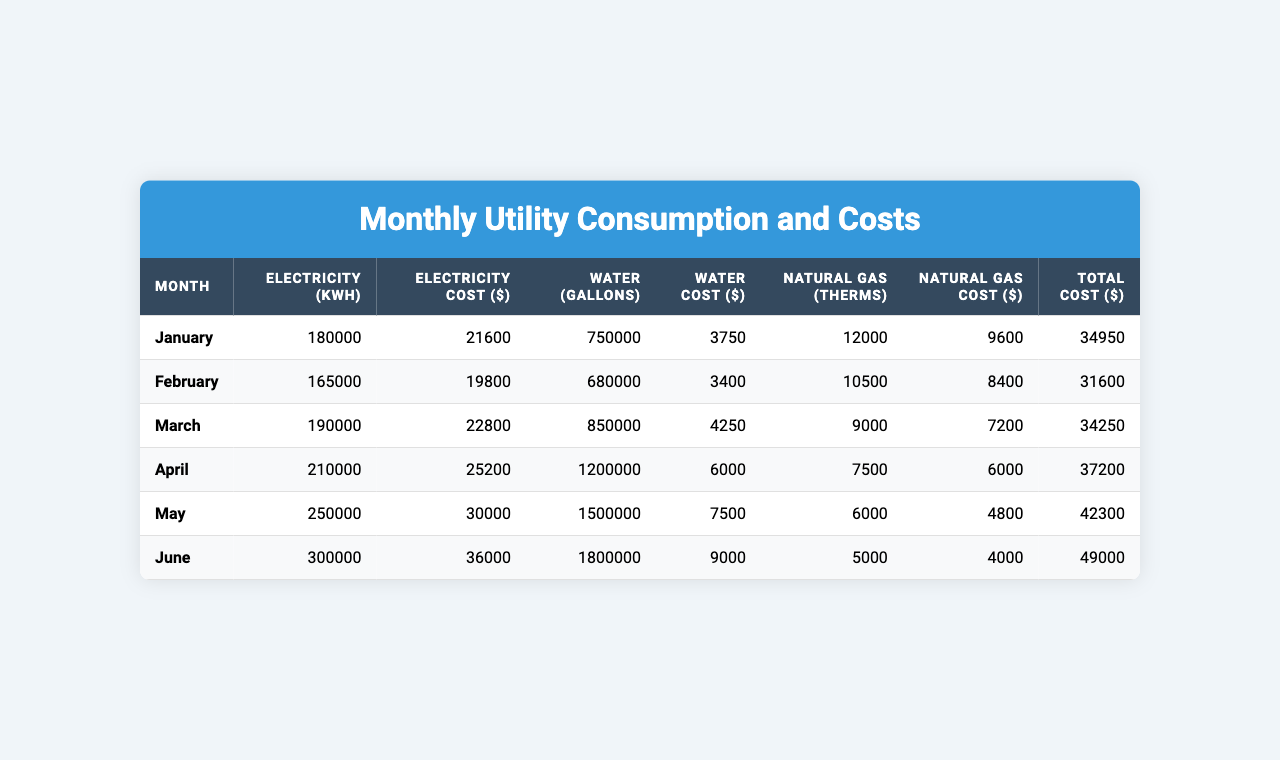What is the total electricity cost for the month of March? The table shows that in March, the electricity cost is listed as $22,800.
Answer: 22800 What month had the highest water consumption? According to the table, June has the highest water consumption with 1,800,000 gallons.
Answer: June What was the average total cost from January to April? The total costs for January, February, March, and April are $34,950, $31,600, $34,250, and $37,200 respectively. Summing them gives $34,950 + $31,600 + $34,250 + $37,200 = $138,000. Dividing by 4, the average is $138,000 / 4 = $34,500.
Answer: 34500 Did natural gas costs decrease from May to June? The table indicates that natural gas cost in May is $4,800 and in June it drops to $4,000. Since $4,800 > $4,000, the cost decreased.
Answer: Yes What is the total cost for all utilities in May? The table lists May's total cost at $42,300 which includes the costs from electricity, water, and natural gas combined.
Answer: 42300 What is the difference in electricity usage between January and June? In January, the electricity usage is 180,000 kWh, and in June it is 300,000 kWh. The difference is calculated as 300,000 - 180,000 = 120,000 kWh.
Answer: 120000 Which month has the lowest water cost, and what is that cost? Looking at the table, February has the lowest water cost at $3,400.
Answer: 3400 If we look at the total costs from February to June, what is the cumulative total? The total costs for February to June are $31,600 (Feb), $34,250 (Mar), $37,200 (Apr), $42,300 (May), and $49,000 (Jun). Adding these up gives $31,600 + $34,250 + $37,200 + $42,300 + $49,000 = $194,350.
Answer: 194350 How much was spent on water between January and March? The water costs from January, February, and March are $3,750, $3,400, and $4,250 respectively. Adding these gives $3,750 + $3,400 + $4,250 = $11,400.
Answer: 11400 What is the trend in total costs from January to June? The total costs from January ($34,950) to June ($49,000) show an increase, indicating that costs rose over these months.
Answer: Costs increased 